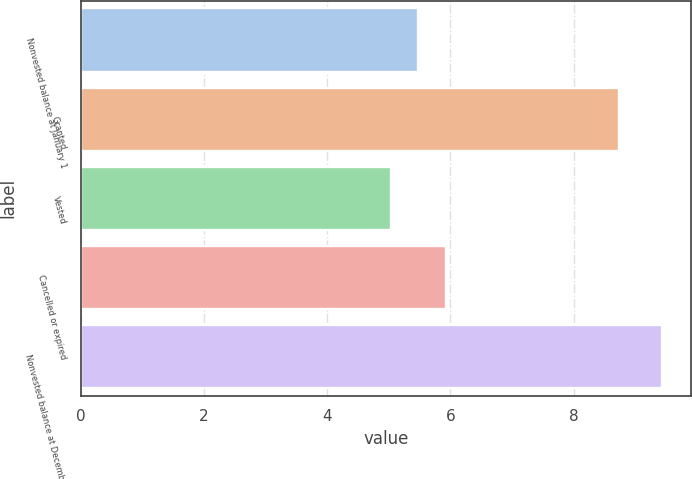<chart> <loc_0><loc_0><loc_500><loc_500><bar_chart><fcel>Nonvested balance at January 1<fcel>Granted<fcel>Vested<fcel>Cancelled or expired<fcel>Nonvested balance at December<nl><fcel>5.48<fcel>8.73<fcel>5.04<fcel>5.92<fcel>9.43<nl></chart> 